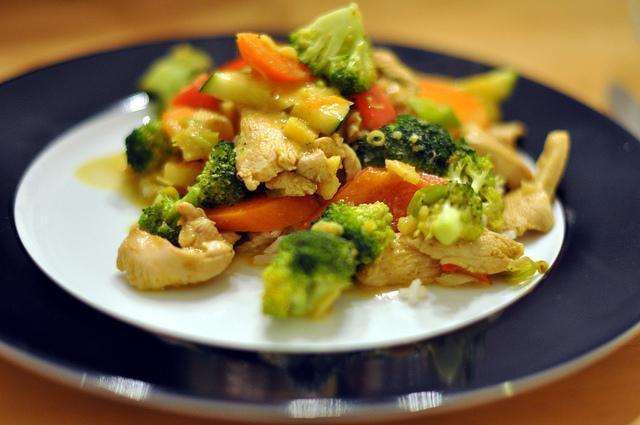How many broccolis are there?
Give a very brief answer. 6. How many carrots are there?
Give a very brief answer. 2. How many cars on this train?
Give a very brief answer. 0. 